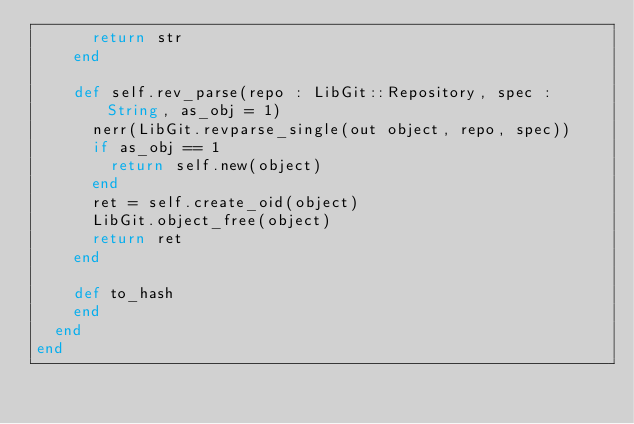Convert code to text. <code><loc_0><loc_0><loc_500><loc_500><_Crystal_>      return str
    end
    
    def self.rev_parse(repo : LibGit::Repository, spec : String, as_obj = 1)
      nerr(LibGit.revparse_single(out object, repo, spec))
      if as_obj == 1
        return self.new(object)
      end
      ret = self.create_oid(object)
      LibGit.object_free(object)
      return ret
    end

    def to_hash
    end
  end
end
</code> 